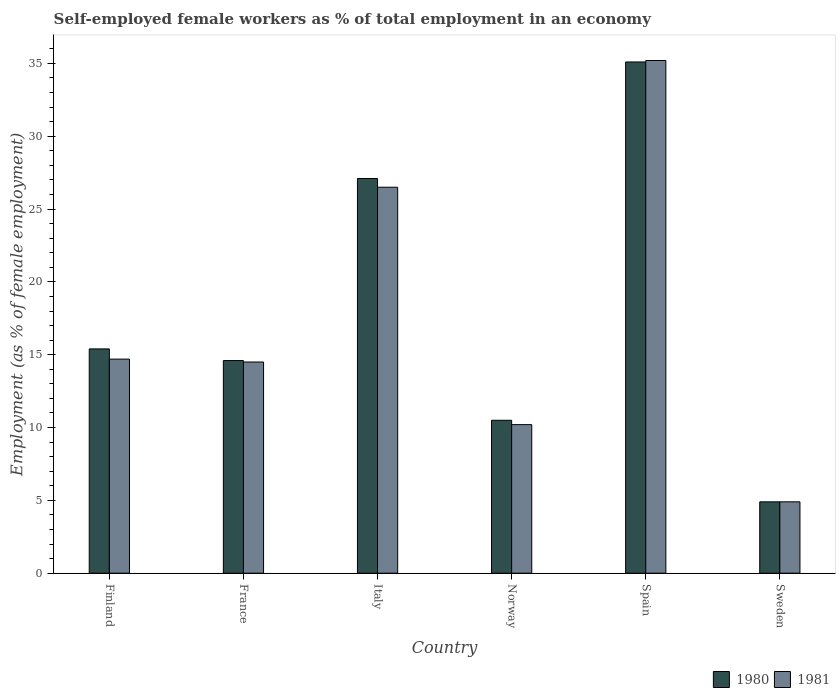How many different coloured bars are there?
Offer a very short reply. 2. How many groups of bars are there?
Give a very brief answer. 6. How many bars are there on the 6th tick from the left?
Ensure brevity in your answer.  2. What is the label of the 4th group of bars from the left?
Offer a terse response. Norway. In how many cases, is the number of bars for a given country not equal to the number of legend labels?
Ensure brevity in your answer.  0. What is the percentage of self-employed female workers in 1981 in Finland?
Your response must be concise. 14.7. Across all countries, what is the maximum percentage of self-employed female workers in 1981?
Offer a very short reply. 35.2. Across all countries, what is the minimum percentage of self-employed female workers in 1981?
Offer a terse response. 4.9. In which country was the percentage of self-employed female workers in 1981 minimum?
Your answer should be very brief. Sweden. What is the total percentage of self-employed female workers in 1980 in the graph?
Your answer should be very brief. 107.6. What is the difference between the percentage of self-employed female workers in 1981 in Finland and that in Italy?
Give a very brief answer. -11.8. What is the difference between the percentage of self-employed female workers in 1981 in Sweden and the percentage of self-employed female workers in 1980 in Italy?
Give a very brief answer. -22.2. What is the average percentage of self-employed female workers in 1981 per country?
Keep it short and to the point. 17.67. What is the difference between the percentage of self-employed female workers of/in 1980 and percentage of self-employed female workers of/in 1981 in Sweden?
Ensure brevity in your answer.  0. In how many countries, is the percentage of self-employed female workers in 1980 greater than 12 %?
Your response must be concise. 4. What is the ratio of the percentage of self-employed female workers in 1980 in Norway to that in Sweden?
Give a very brief answer. 2.14. What is the difference between the highest and the second highest percentage of self-employed female workers in 1980?
Give a very brief answer. -8. What is the difference between the highest and the lowest percentage of self-employed female workers in 1981?
Ensure brevity in your answer.  30.3. In how many countries, is the percentage of self-employed female workers in 1980 greater than the average percentage of self-employed female workers in 1980 taken over all countries?
Give a very brief answer. 2. Is the sum of the percentage of self-employed female workers in 1980 in Norway and Spain greater than the maximum percentage of self-employed female workers in 1981 across all countries?
Offer a terse response. Yes. Are all the bars in the graph horizontal?
Your answer should be compact. No. How many countries are there in the graph?
Offer a terse response. 6. Are the values on the major ticks of Y-axis written in scientific E-notation?
Provide a short and direct response. No. Does the graph contain grids?
Your answer should be compact. No. How many legend labels are there?
Give a very brief answer. 2. What is the title of the graph?
Your answer should be compact. Self-employed female workers as % of total employment in an economy. What is the label or title of the Y-axis?
Your response must be concise. Employment (as % of female employment). What is the Employment (as % of female employment) of 1980 in Finland?
Your answer should be compact. 15.4. What is the Employment (as % of female employment) in 1981 in Finland?
Your answer should be very brief. 14.7. What is the Employment (as % of female employment) of 1980 in France?
Your response must be concise. 14.6. What is the Employment (as % of female employment) in 1981 in France?
Your answer should be compact. 14.5. What is the Employment (as % of female employment) in 1980 in Italy?
Keep it short and to the point. 27.1. What is the Employment (as % of female employment) of 1981 in Italy?
Give a very brief answer. 26.5. What is the Employment (as % of female employment) in 1980 in Norway?
Your answer should be very brief. 10.5. What is the Employment (as % of female employment) of 1981 in Norway?
Offer a terse response. 10.2. What is the Employment (as % of female employment) in 1980 in Spain?
Give a very brief answer. 35.1. What is the Employment (as % of female employment) in 1981 in Spain?
Offer a very short reply. 35.2. What is the Employment (as % of female employment) in 1980 in Sweden?
Offer a very short reply. 4.9. What is the Employment (as % of female employment) in 1981 in Sweden?
Ensure brevity in your answer.  4.9. Across all countries, what is the maximum Employment (as % of female employment) in 1980?
Your answer should be very brief. 35.1. Across all countries, what is the maximum Employment (as % of female employment) in 1981?
Your answer should be very brief. 35.2. Across all countries, what is the minimum Employment (as % of female employment) in 1980?
Provide a short and direct response. 4.9. Across all countries, what is the minimum Employment (as % of female employment) of 1981?
Your answer should be very brief. 4.9. What is the total Employment (as % of female employment) of 1980 in the graph?
Your answer should be compact. 107.6. What is the total Employment (as % of female employment) of 1981 in the graph?
Provide a succinct answer. 106. What is the difference between the Employment (as % of female employment) in 1981 in Finland and that in Italy?
Your response must be concise. -11.8. What is the difference between the Employment (as % of female employment) of 1980 in Finland and that in Norway?
Ensure brevity in your answer.  4.9. What is the difference between the Employment (as % of female employment) of 1981 in Finland and that in Norway?
Offer a very short reply. 4.5. What is the difference between the Employment (as % of female employment) of 1980 in Finland and that in Spain?
Provide a succinct answer. -19.7. What is the difference between the Employment (as % of female employment) in 1981 in Finland and that in Spain?
Offer a very short reply. -20.5. What is the difference between the Employment (as % of female employment) in 1980 in Finland and that in Sweden?
Provide a short and direct response. 10.5. What is the difference between the Employment (as % of female employment) in 1981 in France and that in Norway?
Your answer should be compact. 4.3. What is the difference between the Employment (as % of female employment) of 1980 in France and that in Spain?
Make the answer very short. -20.5. What is the difference between the Employment (as % of female employment) in 1981 in France and that in Spain?
Provide a short and direct response. -20.7. What is the difference between the Employment (as % of female employment) of 1980 in France and that in Sweden?
Ensure brevity in your answer.  9.7. What is the difference between the Employment (as % of female employment) of 1981 in France and that in Sweden?
Offer a terse response. 9.6. What is the difference between the Employment (as % of female employment) of 1981 in Italy and that in Spain?
Ensure brevity in your answer.  -8.7. What is the difference between the Employment (as % of female employment) in 1981 in Italy and that in Sweden?
Make the answer very short. 21.6. What is the difference between the Employment (as % of female employment) of 1980 in Norway and that in Spain?
Offer a very short reply. -24.6. What is the difference between the Employment (as % of female employment) in 1981 in Norway and that in Spain?
Your answer should be very brief. -25. What is the difference between the Employment (as % of female employment) in 1980 in Norway and that in Sweden?
Your response must be concise. 5.6. What is the difference between the Employment (as % of female employment) of 1980 in Spain and that in Sweden?
Provide a short and direct response. 30.2. What is the difference between the Employment (as % of female employment) of 1981 in Spain and that in Sweden?
Your response must be concise. 30.3. What is the difference between the Employment (as % of female employment) in 1980 in Finland and the Employment (as % of female employment) in 1981 in France?
Keep it short and to the point. 0.9. What is the difference between the Employment (as % of female employment) of 1980 in Finland and the Employment (as % of female employment) of 1981 in Italy?
Provide a short and direct response. -11.1. What is the difference between the Employment (as % of female employment) in 1980 in Finland and the Employment (as % of female employment) in 1981 in Spain?
Offer a terse response. -19.8. What is the difference between the Employment (as % of female employment) in 1980 in Finland and the Employment (as % of female employment) in 1981 in Sweden?
Offer a very short reply. 10.5. What is the difference between the Employment (as % of female employment) in 1980 in France and the Employment (as % of female employment) in 1981 in Italy?
Ensure brevity in your answer.  -11.9. What is the difference between the Employment (as % of female employment) in 1980 in France and the Employment (as % of female employment) in 1981 in Spain?
Ensure brevity in your answer.  -20.6. What is the difference between the Employment (as % of female employment) in 1980 in France and the Employment (as % of female employment) in 1981 in Sweden?
Give a very brief answer. 9.7. What is the difference between the Employment (as % of female employment) in 1980 in Italy and the Employment (as % of female employment) in 1981 in Spain?
Offer a very short reply. -8.1. What is the difference between the Employment (as % of female employment) of 1980 in Italy and the Employment (as % of female employment) of 1981 in Sweden?
Make the answer very short. 22.2. What is the difference between the Employment (as % of female employment) in 1980 in Norway and the Employment (as % of female employment) in 1981 in Spain?
Ensure brevity in your answer.  -24.7. What is the difference between the Employment (as % of female employment) of 1980 in Norway and the Employment (as % of female employment) of 1981 in Sweden?
Make the answer very short. 5.6. What is the difference between the Employment (as % of female employment) in 1980 in Spain and the Employment (as % of female employment) in 1981 in Sweden?
Give a very brief answer. 30.2. What is the average Employment (as % of female employment) of 1980 per country?
Your response must be concise. 17.93. What is the average Employment (as % of female employment) of 1981 per country?
Offer a terse response. 17.67. What is the difference between the Employment (as % of female employment) of 1980 and Employment (as % of female employment) of 1981 in Finland?
Your answer should be very brief. 0.7. What is the difference between the Employment (as % of female employment) of 1980 and Employment (as % of female employment) of 1981 in France?
Offer a very short reply. 0.1. What is the difference between the Employment (as % of female employment) in 1980 and Employment (as % of female employment) in 1981 in Italy?
Your answer should be very brief. 0.6. What is the difference between the Employment (as % of female employment) of 1980 and Employment (as % of female employment) of 1981 in Sweden?
Provide a short and direct response. 0. What is the ratio of the Employment (as % of female employment) in 1980 in Finland to that in France?
Offer a very short reply. 1.05. What is the ratio of the Employment (as % of female employment) in 1981 in Finland to that in France?
Provide a short and direct response. 1.01. What is the ratio of the Employment (as % of female employment) in 1980 in Finland to that in Italy?
Give a very brief answer. 0.57. What is the ratio of the Employment (as % of female employment) in 1981 in Finland to that in Italy?
Provide a succinct answer. 0.55. What is the ratio of the Employment (as % of female employment) of 1980 in Finland to that in Norway?
Offer a terse response. 1.47. What is the ratio of the Employment (as % of female employment) of 1981 in Finland to that in Norway?
Ensure brevity in your answer.  1.44. What is the ratio of the Employment (as % of female employment) of 1980 in Finland to that in Spain?
Provide a succinct answer. 0.44. What is the ratio of the Employment (as % of female employment) in 1981 in Finland to that in Spain?
Ensure brevity in your answer.  0.42. What is the ratio of the Employment (as % of female employment) of 1980 in Finland to that in Sweden?
Make the answer very short. 3.14. What is the ratio of the Employment (as % of female employment) of 1981 in Finland to that in Sweden?
Provide a short and direct response. 3. What is the ratio of the Employment (as % of female employment) in 1980 in France to that in Italy?
Keep it short and to the point. 0.54. What is the ratio of the Employment (as % of female employment) of 1981 in France to that in Italy?
Your answer should be very brief. 0.55. What is the ratio of the Employment (as % of female employment) in 1980 in France to that in Norway?
Your response must be concise. 1.39. What is the ratio of the Employment (as % of female employment) in 1981 in France to that in Norway?
Your response must be concise. 1.42. What is the ratio of the Employment (as % of female employment) of 1980 in France to that in Spain?
Your answer should be compact. 0.42. What is the ratio of the Employment (as % of female employment) in 1981 in France to that in Spain?
Offer a very short reply. 0.41. What is the ratio of the Employment (as % of female employment) of 1980 in France to that in Sweden?
Ensure brevity in your answer.  2.98. What is the ratio of the Employment (as % of female employment) of 1981 in France to that in Sweden?
Your answer should be very brief. 2.96. What is the ratio of the Employment (as % of female employment) of 1980 in Italy to that in Norway?
Offer a very short reply. 2.58. What is the ratio of the Employment (as % of female employment) of 1981 in Italy to that in Norway?
Your answer should be compact. 2.6. What is the ratio of the Employment (as % of female employment) of 1980 in Italy to that in Spain?
Provide a succinct answer. 0.77. What is the ratio of the Employment (as % of female employment) of 1981 in Italy to that in Spain?
Give a very brief answer. 0.75. What is the ratio of the Employment (as % of female employment) in 1980 in Italy to that in Sweden?
Keep it short and to the point. 5.53. What is the ratio of the Employment (as % of female employment) in 1981 in Italy to that in Sweden?
Make the answer very short. 5.41. What is the ratio of the Employment (as % of female employment) of 1980 in Norway to that in Spain?
Your answer should be very brief. 0.3. What is the ratio of the Employment (as % of female employment) of 1981 in Norway to that in Spain?
Your response must be concise. 0.29. What is the ratio of the Employment (as % of female employment) in 1980 in Norway to that in Sweden?
Your answer should be very brief. 2.14. What is the ratio of the Employment (as % of female employment) in 1981 in Norway to that in Sweden?
Your answer should be very brief. 2.08. What is the ratio of the Employment (as % of female employment) in 1980 in Spain to that in Sweden?
Provide a succinct answer. 7.16. What is the ratio of the Employment (as % of female employment) of 1981 in Spain to that in Sweden?
Your answer should be very brief. 7.18. What is the difference between the highest and the second highest Employment (as % of female employment) of 1980?
Provide a succinct answer. 8. What is the difference between the highest and the lowest Employment (as % of female employment) of 1980?
Give a very brief answer. 30.2. What is the difference between the highest and the lowest Employment (as % of female employment) in 1981?
Your answer should be very brief. 30.3. 